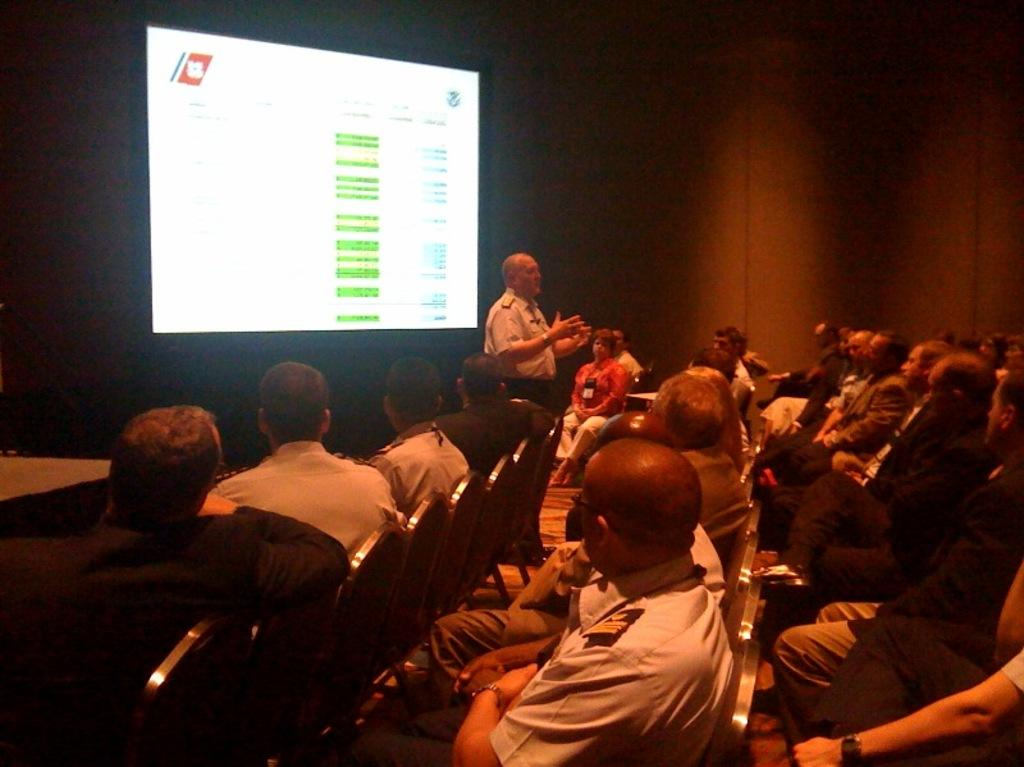What are the people in the image doing? The people in the image are sitting on chairs. What is the standing person doing in the image? The standing person is in front of a screen. What is the standing person's focus in the image? The standing person is looking at the people sitting on chairs. What type of liquid is being poured on the chairs in the image? There is no liquid being poured on the chairs in the image; the people are simply sitting on them. 